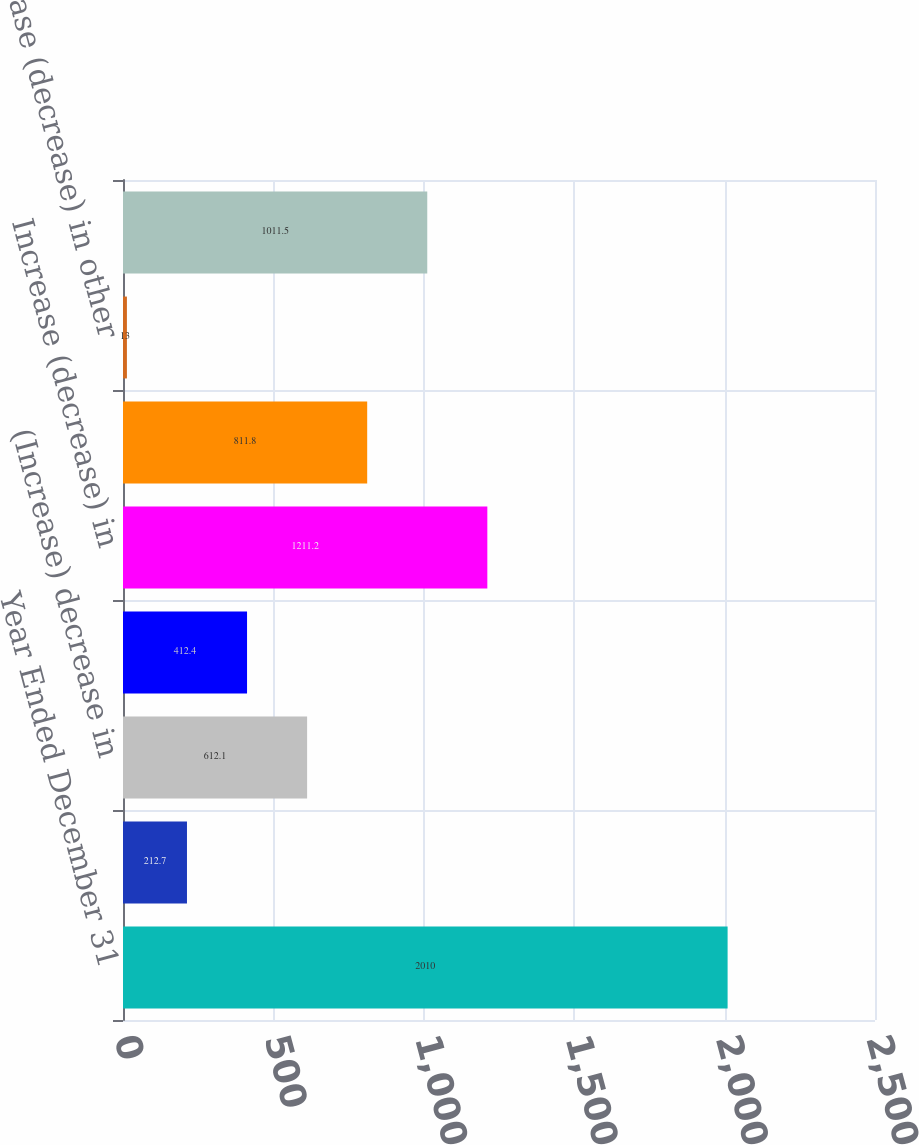<chart> <loc_0><loc_0><loc_500><loc_500><bar_chart><fcel>Year Ended December 31<fcel>(Increase) decrease in trade<fcel>(Increase) decrease in<fcel>(Increase) decrease in prepaid<fcel>Increase (decrease) in<fcel>Increase (decrease) in accrued<fcel>Increase (decrease) in other<fcel>Net change in operating assets<nl><fcel>2010<fcel>212.7<fcel>612.1<fcel>412.4<fcel>1211.2<fcel>811.8<fcel>13<fcel>1011.5<nl></chart> 